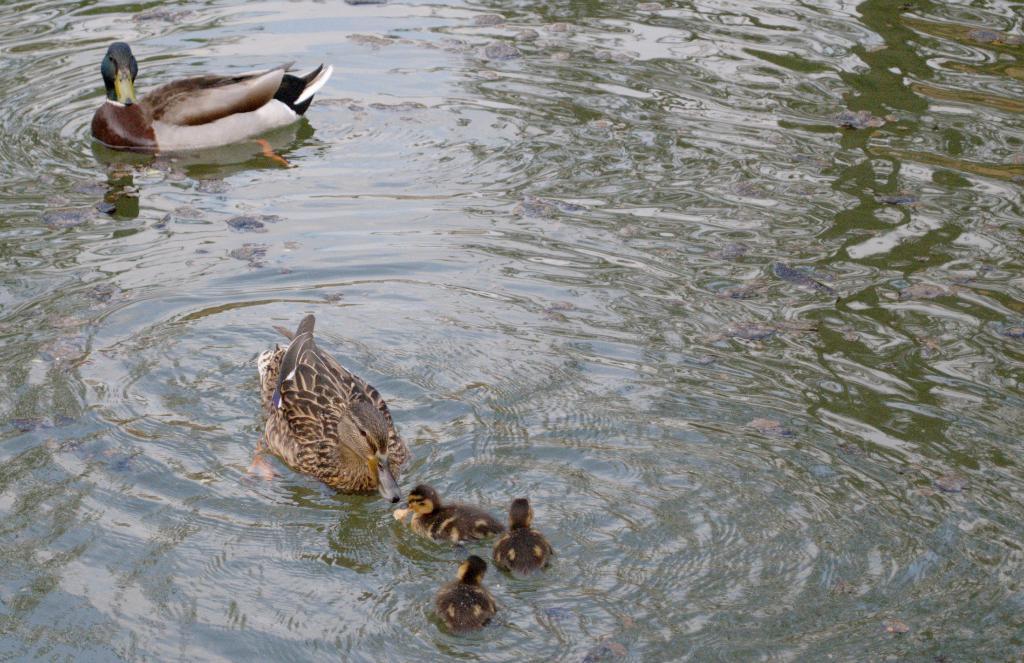How would you summarize this image in a sentence or two? In this image we can see ducks and ducklings on the water. 